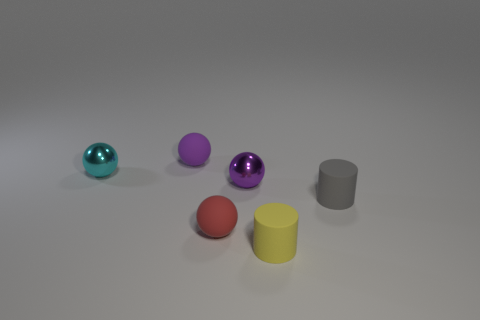Subtract all tiny cyan shiny balls. How many balls are left? 3 Subtract all red balls. How many balls are left? 3 Add 1 small yellow cylinders. How many objects exist? 7 Subtract all cylinders. How many objects are left? 4 Subtract 0 blue spheres. How many objects are left? 6 Subtract 2 balls. How many balls are left? 2 Subtract all green spheres. Subtract all blue cubes. How many spheres are left? 4 Subtract all blue balls. How many gray cylinders are left? 1 Subtract all red spheres. Subtract all small red objects. How many objects are left? 4 Add 4 tiny gray rubber things. How many tiny gray rubber things are left? 5 